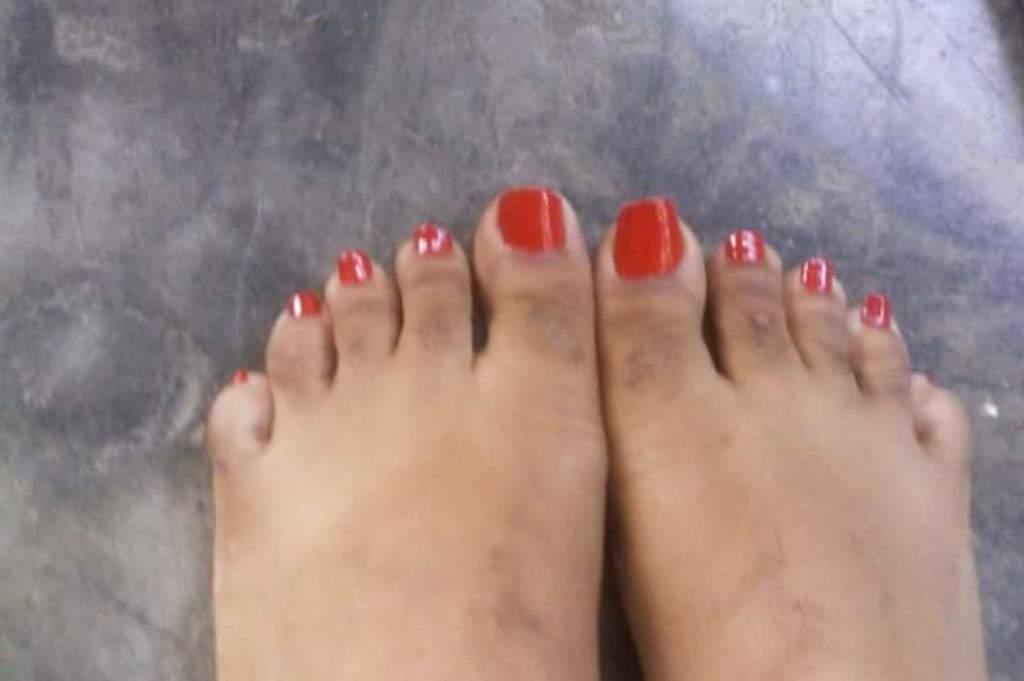In one or two sentences, can you explain what this image depicts? In this image I can see the legs of a person. 